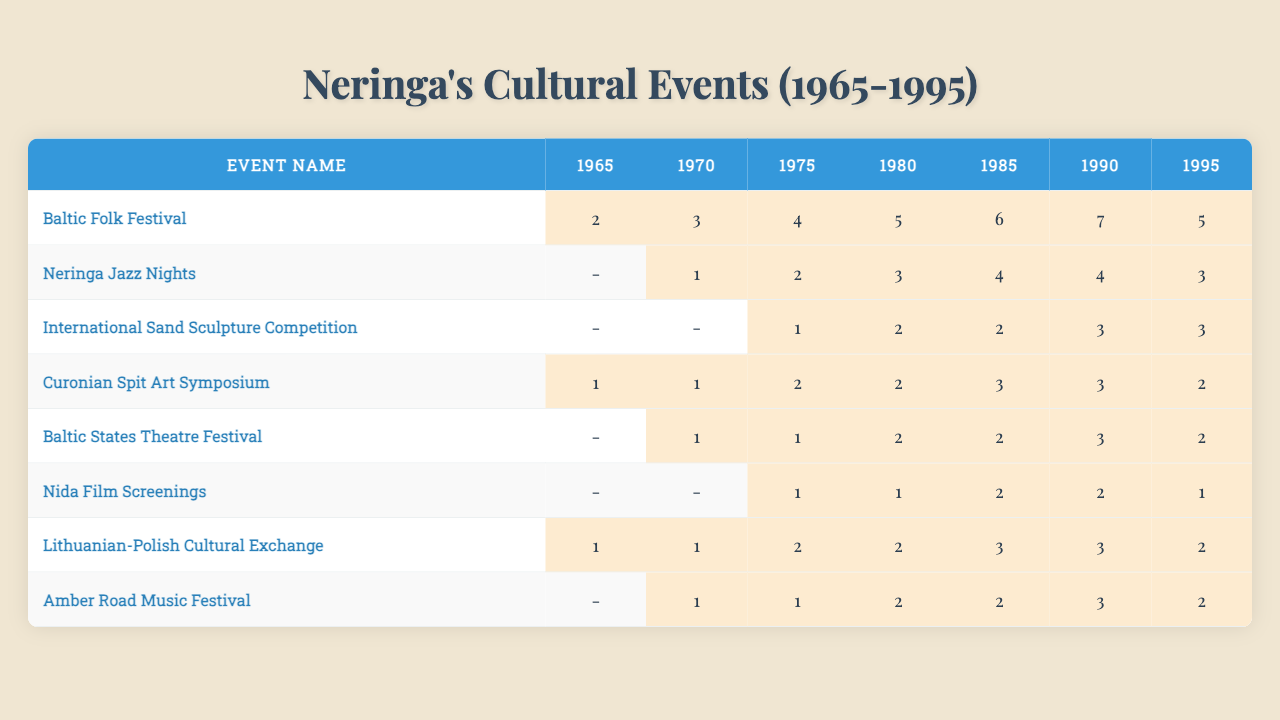What was the frequency of the Baltic Folk Festival in 1980? The table shows that the frequency of the Baltic Folk Festival in 1980 is 5.
Answer: 5 Which event had the highest frequency in 1990? By looking at the 1990 column, the Baltic Folk Festival had the highest frequency of 7 compared to other events.
Answer: Baltic Folk Festival What is the total frequency of events for the International Sand Sculpture Competition from 1965 to 1995? The frequencies for the International Sand Sculpture Competition are 0, 0, 1, 2, 2, 3, 3. Adding these gives 0 + 0 + 1 + 2 + 2 + 3 + 3 = 11.
Answer: 11 Did the frequency of Neringa Jazz Nights increase between 1985 and 1990? The frequency of Neringa Jazz Nights in 1985 is 4, and in 1990 it is 4 as well, showing there was no increase.
Answer: No What is the average frequency of the Curonian Spit Art Symposium from 1965 to 1995? The frequencies are 1, 1, 2, 2, 3, 3, 2. Adding these gives 1 + 1 + 2 + 2 + 3 + 3 + 2 = 14. There are 7 years, so the average is 14 / 7 = 2.
Answer: 2 Which event consistently had a frequency of 3 or more in the years provided? The Baltic Folk Festival and the Lithuanian-Polish Cultural Exchange both had a frequency of 3 or more from 1985 to 1990.
Answer: Baltic Folk Festival, Lithuanian-Polish Cultural Exchange How many different events had a frequency of 2 in 1985? In 1985, the events with a frequency of 2 are the International Sand Sculpture Competition, Curonian Spit Art Symposium, Baltic States Theatre Festival, and Amber Road Music Festival, totaling 4 events.
Answer: 4 What was the change in frequency for the Nida Film Screenings from 1975 to 1995? The frequency in 1975 is 1, and in 1995 it is 1 as well, showing no change occurred.
Answer: No change For which event did the frequency peak in the early 1990s? The Baltic Folk Festival peaked in the early 1990s with a frequency of 7 in 1990.
Answer: Baltic Folk Festival Which event had the lowest frequency across all years? By examining the frequencies, the Nida Film Screenings had a consistent low frequency, peaking at only 2 and recorded 0 for several years.
Answer: Nida Film Screenings 